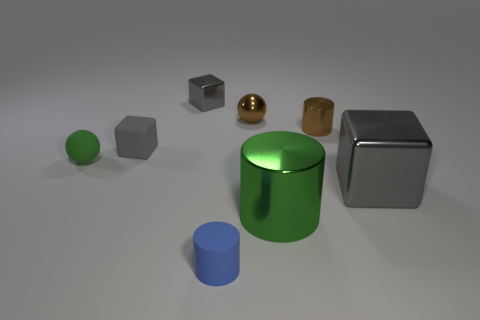Add 1 big gray objects. How many objects exist? 9 Subtract all cubes. How many objects are left? 5 Subtract all tiny cylinders. Subtract all small cubes. How many objects are left? 4 Add 1 tiny gray matte objects. How many tiny gray matte objects are left? 2 Add 2 big blue balls. How many big blue balls exist? 2 Subtract 0 cyan cylinders. How many objects are left? 8 